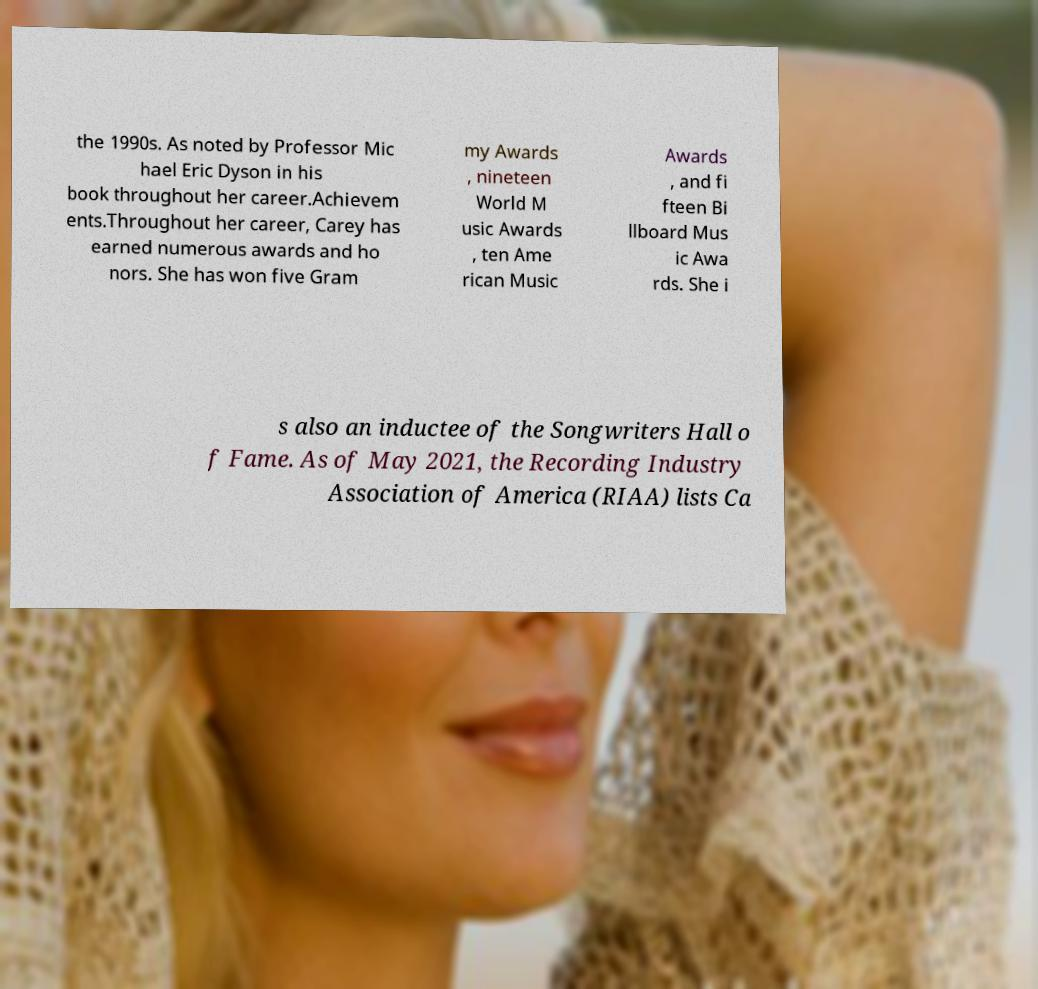Please read and relay the text visible in this image. What does it say? the 1990s. As noted by Professor Mic hael Eric Dyson in his book throughout her career.Achievem ents.Throughout her career, Carey has earned numerous awards and ho nors. She has won five Gram my Awards , nineteen World M usic Awards , ten Ame rican Music Awards , and fi fteen Bi llboard Mus ic Awa rds. She i s also an inductee of the Songwriters Hall o f Fame. As of May 2021, the Recording Industry Association of America (RIAA) lists Ca 